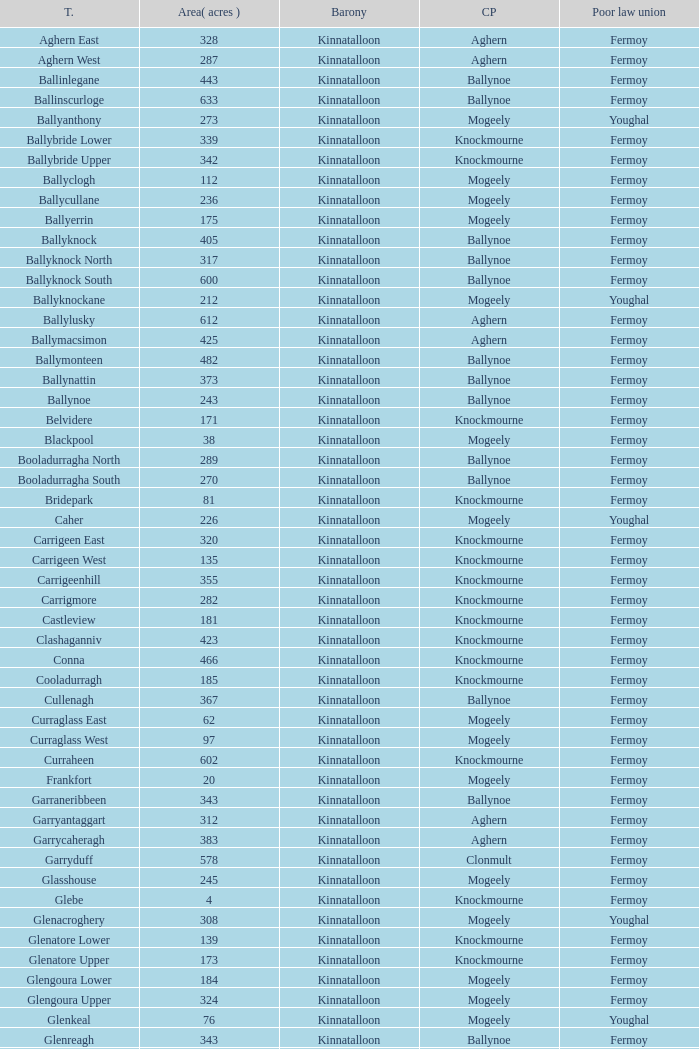Would you mind parsing the complete table? {'header': ['T.', 'Area( acres )', 'Barony', 'CP', 'Poor law union'], 'rows': [['Aghern East', '328', 'Kinnatalloon', 'Aghern', 'Fermoy'], ['Aghern West', '287', 'Kinnatalloon', 'Aghern', 'Fermoy'], ['Ballinlegane', '443', 'Kinnatalloon', 'Ballynoe', 'Fermoy'], ['Ballinscurloge', '633', 'Kinnatalloon', 'Ballynoe', 'Fermoy'], ['Ballyanthony', '273', 'Kinnatalloon', 'Mogeely', 'Youghal'], ['Ballybride Lower', '339', 'Kinnatalloon', 'Knockmourne', 'Fermoy'], ['Ballybride Upper', '342', 'Kinnatalloon', 'Knockmourne', 'Fermoy'], ['Ballyclogh', '112', 'Kinnatalloon', 'Mogeely', 'Fermoy'], ['Ballycullane', '236', 'Kinnatalloon', 'Mogeely', 'Fermoy'], ['Ballyerrin', '175', 'Kinnatalloon', 'Mogeely', 'Fermoy'], ['Ballyknock', '405', 'Kinnatalloon', 'Ballynoe', 'Fermoy'], ['Ballyknock North', '317', 'Kinnatalloon', 'Ballynoe', 'Fermoy'], ['Ballyknock South', '600', 'Kinnatalloon', 'Ballynoe', 'Fermoy'], ['Ballyknockane', '212', 'Kinnatalloon', 'Mogeely', 'Youghal'], ['Ballylusky', '612', 'Kinnatalloon', 'Aghern', 'Fermoy'], ['Ballymacsimon', '425', 'Kinnatalloon', 'Aghern', 'Fermoy'], ['Ballymonteen', '482', 'Kinnatalloon', 'Ballynoe', 'Fermoy'], ['Ballynattin', '373', 'Kinnatalloon', 'Ballynoe', 'Fermoy'], ['Ballynoe', '243', 'Kinnatalloon', 'Ballynoe', 'Fermoy'], ['Belvidere', '171', 'Kinnatalloon', 'Knockmourne', 'Fermoy'], ['Blackpool', '38', 'Kinnatalloon', 'Mogeely', 'Fermoy'], ['Booladurragha North', '289', 'Kinnatalloon', 'Ballynoe', 'Fermoy'], ['Booladurragha South', '270', 'Kinnatalloon', 'Ballynoe', 'Fermoy'], ['Bridepark', '81', 'Kinnatalloon', 'Knockmourne', 'Fermoy'], ['Caher', '226', 'Kinnatalloon', 'Mogeely', 'Youghal'], ['Carrigeen East', '320', 'Kinnatalloon', 'Knockmourne', 'Fermoy'], ['Carrigeen West', '135', 'Kinnatalloon', 'Knockmourne', 'Fermoy'], ['Carrigeenhill', '355', 'Kinnatalloon', 'Knockmourne', 'Fermoy'], ['Carrigmore', '282', 'Kinnatalloon', 'Knockmourne', 'Fermoy'], ['Castleview', '181', 'Kinnatalloon', 'Knockmourne', 'Fermoy'], ['Clashaganniv', '423', 'Kinnatalloon', 'Knockmourne', 'Fermoy'], ['Conna', '466', 'Kinnatalloon', 'Knockmourne', 'Fermoy'], ['Cooladurragh', '185', 'Kinnatalloon', 'Knockmourne', 'Fermoy'], ['Cullenagh', '367', 'Kinnatalloon', 'Ballynoe', 'Fermoy'], ['Curraglass East', '62', 'Kinnatalloon', 'Mogeely', 'Fermoy'], ['Curraglass West', '97', 'Kinnatalloon', 'Mogeely', 'Fermoy'], ['Curraheen', '602', 'Kinnatalloon', 'Knockmourne', 'Fermoy'], ['Frankfort', '20', 'Kinnatalloon', 'Mogeely', 'Fermoy'], ['Garraneribbeen', '343', 'Kinnatalloon', 'Ballynoe', 'Fermoy'], ['Garryantaggart', '312', 'Kinnatalloon', 'Aghern', 'Fermoy'], ['Garrycaheragh', '383', 'Kinnatalloon', 'Aghern', 'Fermoy'], ['Garryduff', '578', 'Kinnatalloon', 'Clonmult', 'Fermoy'], ['Glasshouse', '245', 'Kinnatalloon', 'Mogeely', 'Fermoy'], ['Glebe', '4', 'Kinnatalloon', 'Knockmourne', 'Fermoy'], ['Glenacroghery', '308', 'Kinnatalloon', 'Mogeely', 'Youghal'], ['Glenatore Lower', '139', 'Kinnatalloon', 'Knockmourne', 'Fermoy'], ['Glenatore Upper', '173', 'Kinnatalloon', 'Knockmourne', 'Fermoy'], ['Glengoura Lower', '184', 'Kinnatalloon', 'Mogeely', 'Fermoy'], ['Glengoura Upper', '324', 'Kinnatalloon', 'Mogeely', 'Fermoy'], ['Glenkeal', '76', 'Kinnatalloon', 'Mogeely', 'Youghal'], ['Glenreagh', '343', 'Kinnatalloon', 'Ballynoe', 'Fermoy'], ['Glentane', '274', 'Kinnatalloon', 'Ballynoe', 'Fermoy'], ['Glentrasna', '284', 'Kinnatalloon', 'Aghern', 'Fermoy'], ['Glentrasna North', '219', 'Kinnatalloon', 'Aghern', 'Fermoy'], ['Glentrasna South', '220', 'Kinnatalloon', 'Aghern', 'Fermoy'], ['Gortnafira', '78', 'Kinnatalloon', 'Mogeely', 'Fermoy'], ['Inchyallagh', '8', 'Kinnatalloon', 'Mogeely', 'Fermoy'], ['Kilclare Lower', '109', 'Kinnatalloon', 'Knockmourne', 'Fermoy'], ['Kilclare Upper', '493', 'Kinnatalloon', 'Knockmourne', 'Fermoy'], ['Kilcronat', '516', 'Kinnatalloon', 'Mogeely', 'Youghal'], ['Kilcronatmountain', '385', 'Kinnatalloon', 'Mogeely', 'Youghal'], ['Killasseragh', '340', 'Kinnatalloon', 'Ballynoe', 'Fermoy'], ['Killavarilly', '372', 'Kinnatalloon', 'Knockmourne', 'Fermoy'], ['Kilmacow', '316', 'Kinnatalloon', 'Mogeely', 'Fermoy'], ['Kilnafurrery', '256', 'Kinnatalloon', 'Mogeely', 'Youghal'], ['Kilphillibeen', '535', 'Kinnatalloon', 'Ballynoe', 'Fermoy'], ['Knockacool', '404', 'Kinnatalloon', 'Mogeely', 'Youghal'], ['Knockakeo', '296', 'Kinnatalloon', 'Ballynoe', 'Fermoy'], ['Knockanarrig', '215', 'Kinnatalloon', 'Mogeely', 'Youghal'], ['Knockastickane', '164', 'Kinnatalloon', 'Knockmourne', 'Fermoy'], ['Knocknagapple', '293', 'Kinnatalloon', 'Aghern', 'Fermoy'], ['Lackbrack', '84', 'Kinnatalloon', 'Mogeely', 'Fermoy'], ['Lacken', '262', 'Kinnatalloon', 'Mogeely', 'Youghal'], ['Lackenbehy', '101', 'Kinnatalloon', 'Mogeely', 'Fermoy'], ['Limekilnclose', '41', 'Kinnatalloon', 'Mogeely', 'Lismore'], ['Lisnabrin Lower', '114', 'Kinnatalloon', 'Mogeely', 'Fermoy'], ['Lisnabrin North', '217', 'Kinnatalloon', 'Mogeely', 'Fermoy'], ['Lisnabrin South', '180', 'Kinnatalloon', 'Mogeely', 'Fermoy'], ['Lisnabrinlodge', '28', 'Kinnatalloon', 'Mogeely', 'Fermoy'], ['Littlegrace', '50', 'Kinnatalloon', 'Knockmourne', 'Lismore'], ['Longueville North', '355', 'Kinnatalloon', 'Ballynoe', 'Fermoy'], ['Longueville South', '271', 'Kinnatalloon', 'Ballynoe', 'Fermoy'], ['Lyre', '160', 'Kinnatalloon', 'Mogeely', 'Youghal'], ['Lyre Mountain', '360', 'Kinnatalloon', 'Mogeely', 'Youghal'], ['Mogeely Lower', '304', 'Kinnatalloon', 'Mogeely', 'Fermoy'], ['Mogeely Upper', '247', 'Kinnatalloon', 'Mogeely', 'Fermoy'], ['Monagown', '491', 'Kinnatalloon', 'Knockmourne', 'Fermoy'], ['Monaloo', '458', 'Kinnatalloon', 'Mogeely', 'Youghal'], ['Mountprospect', '102', 'Kinnatalloon', 'Mogeely', 'Fermoy'], ['Park', '119', 'Kinnatalloon', 'Aghern', 'Fermoy'], ['Poundfields', '15', 'Kinnatalloon', 'Mogeely', 'Fermoy'], ['Rathdrum', '336', 'Kinnatalloon', 'Ballynoe', 'Fermoy'], ['Rathdrum', '339', 'Kinnatalloon', 'Britway', 'Fermoy'], ['Reanduff', '318', 'Kinnatalloon', 'Mogeely', 'Youghal'], ['Rearour North', '208', 'Kinnatalloon', 'Mogeely', 'Youghal'], ['Rearour South', '223', 'Kinnatalloon', 'Mogeely', 'Youghal'], ['Rosybower', '105', 'Kinnatalloon', 'Mogeely', 'Fermoy'], ['Sandyhill', '263', 'Kinnatalloon', 'Mogeely', 'Youghal'], ['Shanaboola', '190', 'Kinnatalloon', 'Ballynoe', 'Fermoy'], ['Shanakill Lower', '244', 'Kinnatalloon', 'Mogeely', 'Fermoy'], ['Shanakill Upper', '244', 'Kinnatalloon', 'Mogeely', 'Fermoy'], ['Slieveadoctor', '260', 'Kinnatalloon', 'Mogeely', 'Fermoy'], ['Templevally', '330', 'Kinnatalloon', 'Mogeely', 'Fermoy'], ['Vinepark', '7', 'Kinnatalloon', 'Mogeely', 'Fermoy']]} Name the civil parish for garryduff Clonmult. 